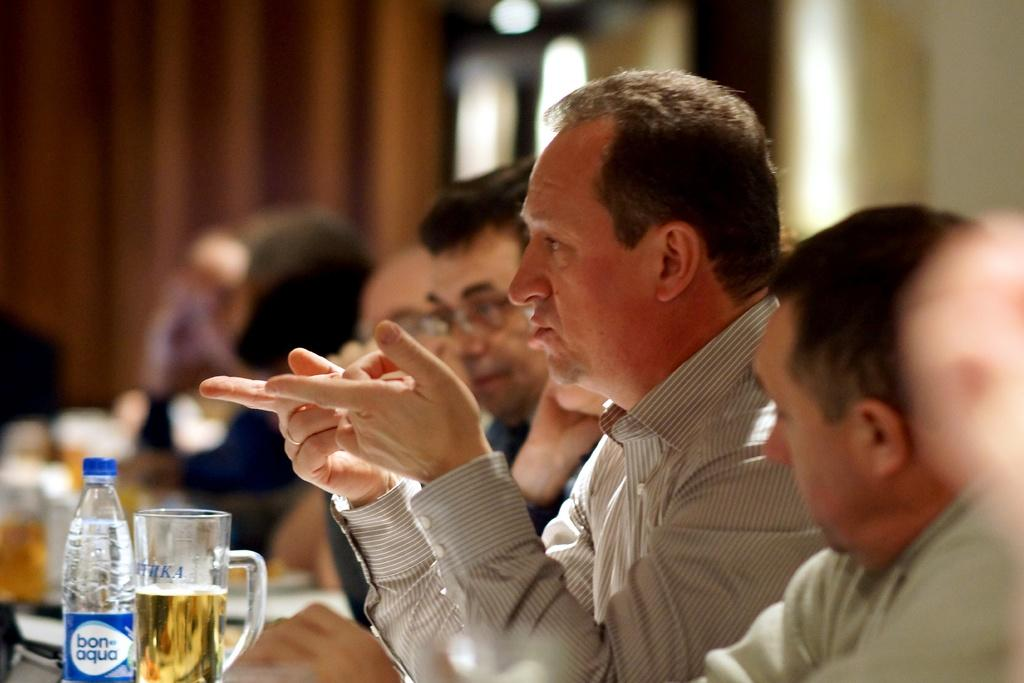Who or what is present in the image? There are people in the image. What are the people doing in the image? The people are sitting on chairs. Where are the chairs located in relation to the table? The chairs are in front of a table. What can be seen on the table in the image? There is a glass and a bottle on the table. What type of flower is sitting next to the people in the image? There is no flower present in the image; the people are sitting on chairs in front of a table with a glass and a bottle. 